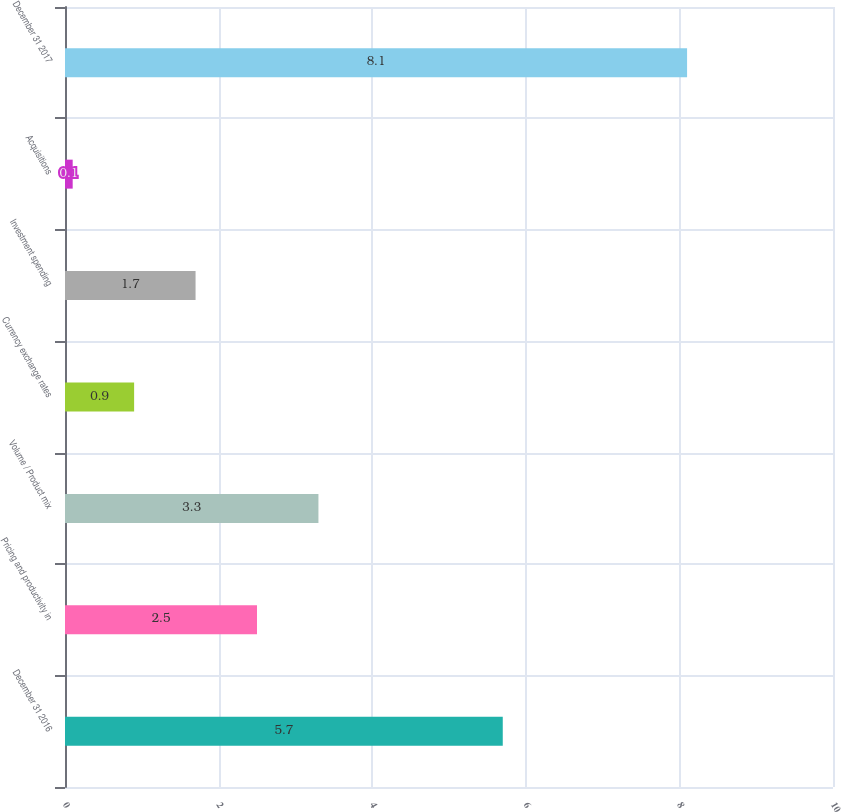Convert chart. <chart><loc_0><loc_0><loc_500><loc_500><bar_chart><fcel>December 31 2016<fcel>Pricing and productivity in<fcel>Volume / Product mix<fcel>Currency exchange rates<fcel>Investment spending<fcel>Acquisitions<fcel>December 31 2017<nl><fcel>5.7<fcel>2.5<fcel>3.3<fcel>0.9<fcel>1.7<fcel>0.1<fcel>8.1<nl></chart> 